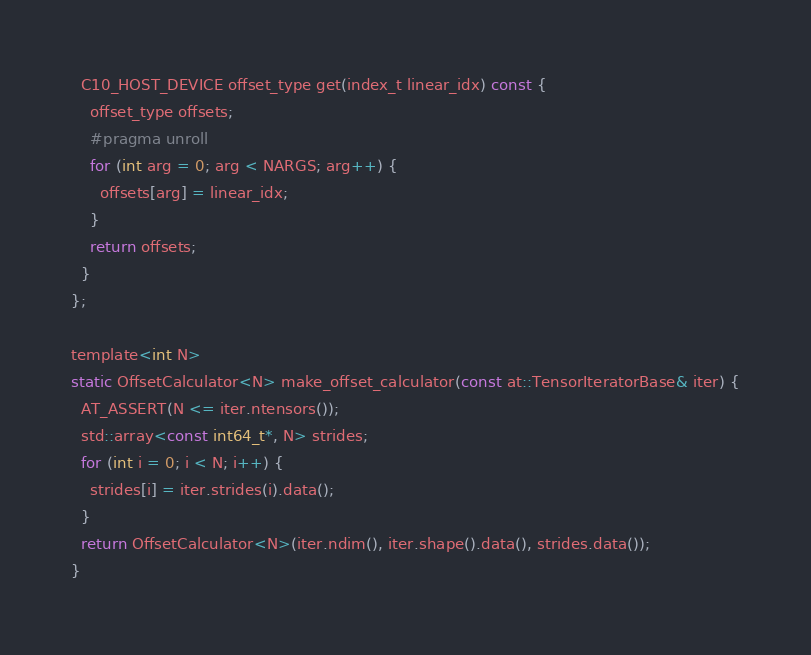Convert code to text. <code><loc_0><loc_0><loc_500><loc_500><_Cuda_>  C10_HOST_DEVICE offset_type get(index_t linear_idx) const {
    offset_type offsets;
    #pragma unroll
    for (int arg = 0; arg < NARGS; arg++) {
      offsets[arg] = linear_idx;
    }
    return offsets;
  }
};

template<int N>
static OffsetCalculator<N> make_offset_calculator(const at::TensorIteratorBase& iter) {
  AT_ASSERT(N <= iter.ntensors());
  std::array<const int64_t*, N> strides;
  for (int i = 0; i < N; i++) {
    strides[i] = iter.strides(i).data();
  }
  return OffsetCalculator<N>(iter.ndim(), iter.shape().data(), strides.data());
}
</code> 